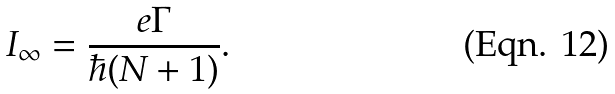Convert formula to latex. <formula><loc_0><loc_0><loc_500><loc_500>I _ { \infty } = \frac { e \Gamma } { \hbar { ( } N + 1 ) } .</formula> 